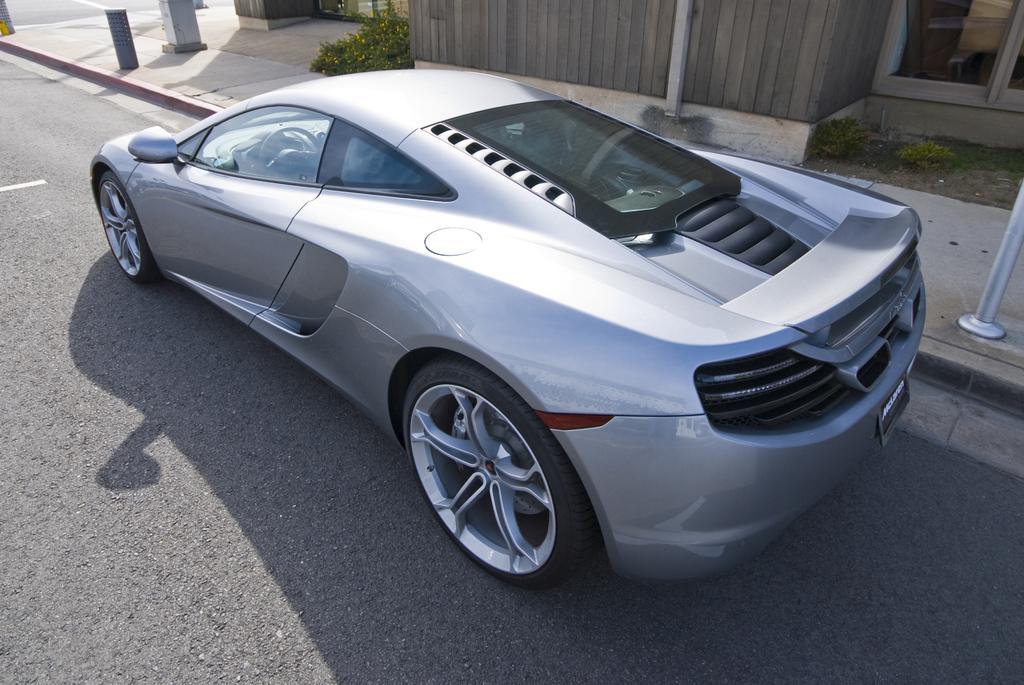In one or two sentences, can you explain what this image depicts? In this picture I can see there is a car, it is in silver color and it has two doors and on to right there is a building and plants. 